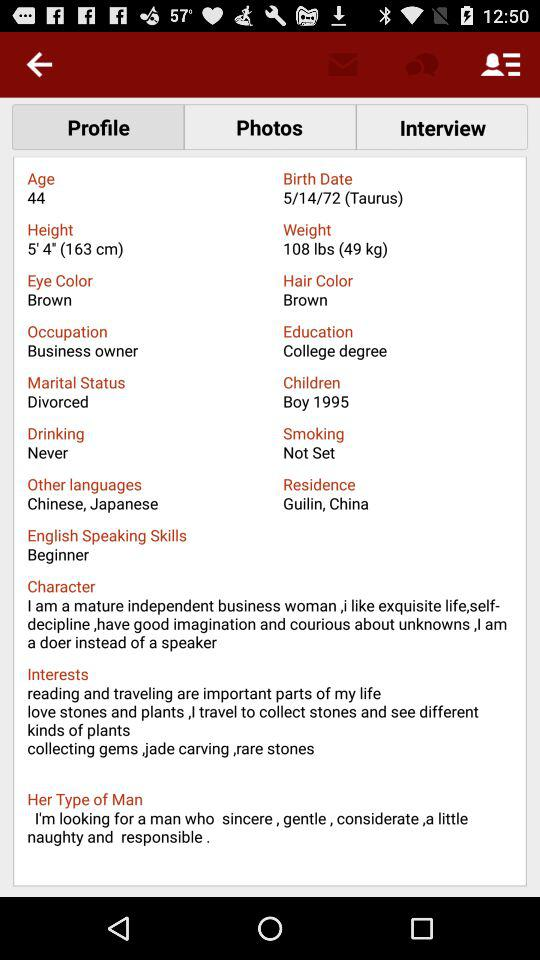What is the marital status? The marital status is "Divorced". 